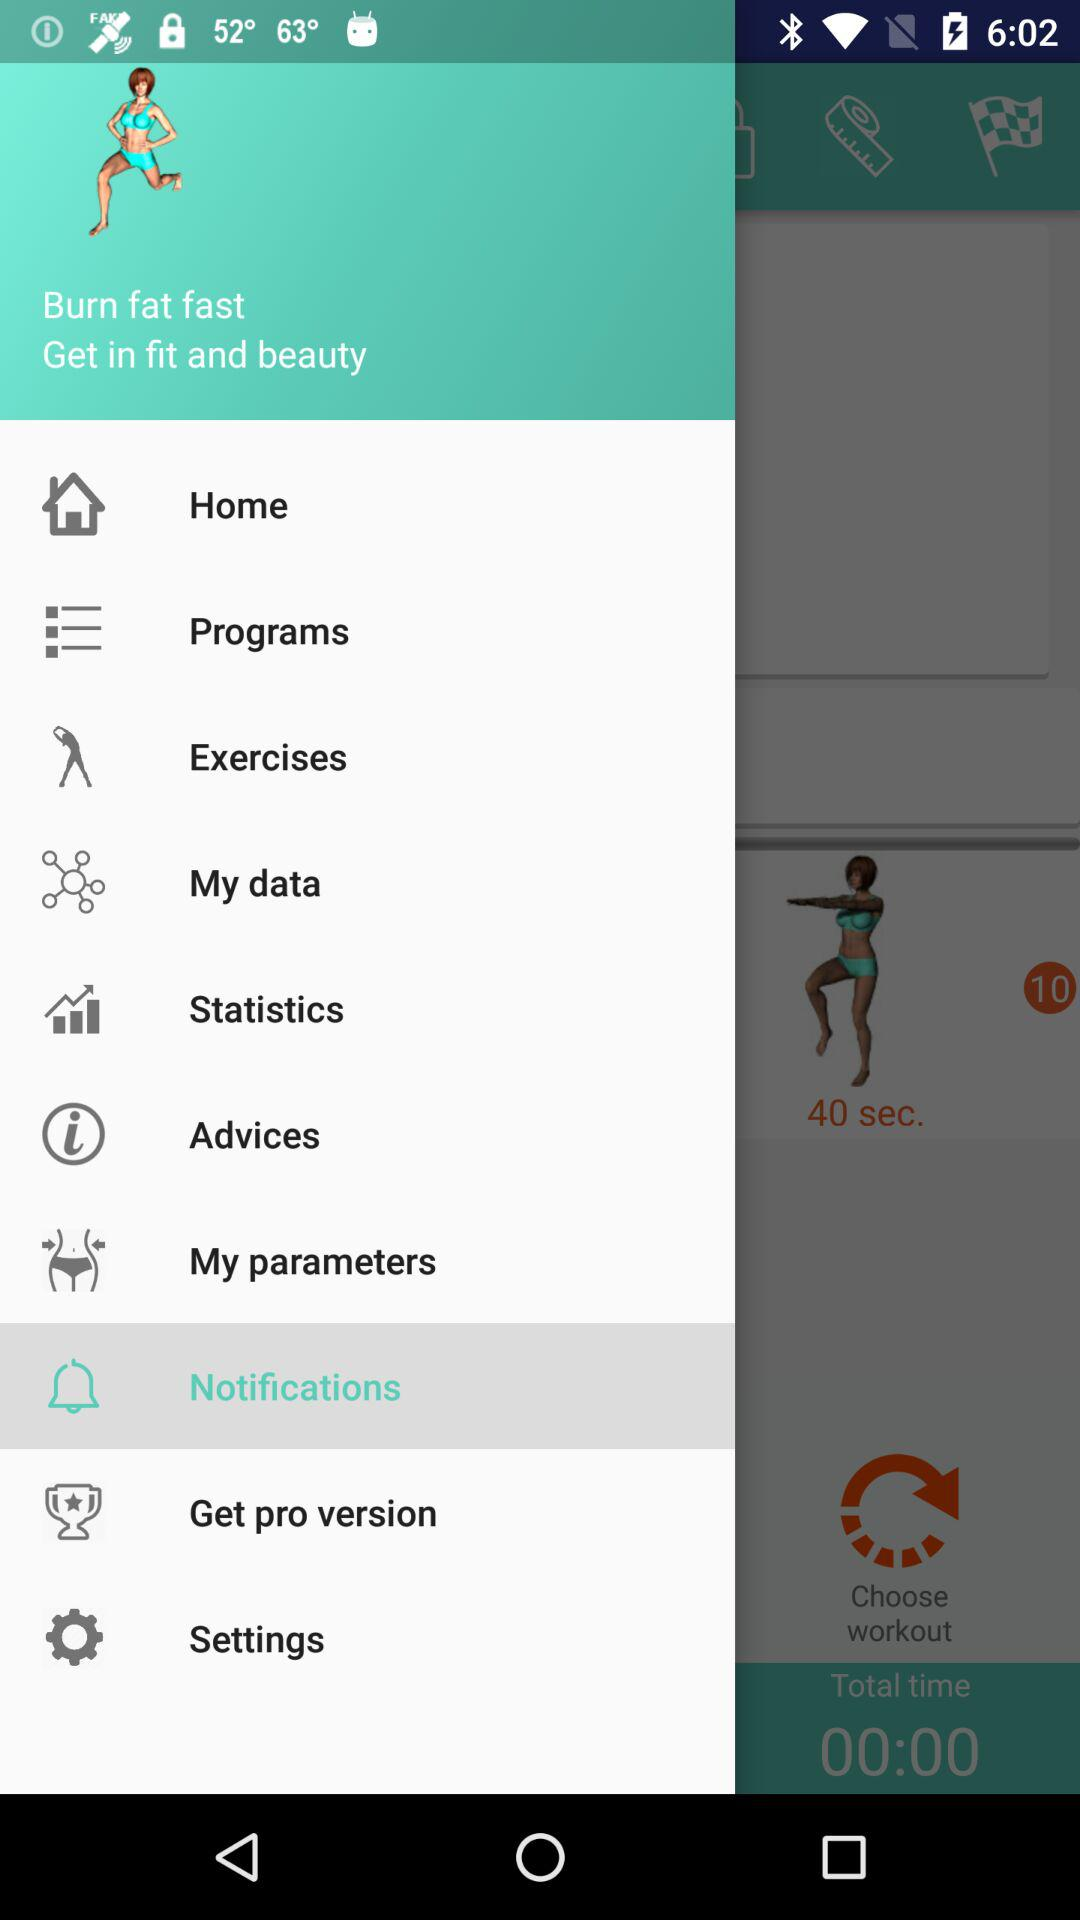What is the application name?
When the provided information is insufficient, respond with <no answer>. <no answer> 